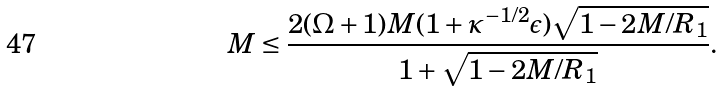Convert formula to latex. <formula><loc_0><loc_0><loc_500><loc_500>M \leq \frac { 2 ( \Omega + 1 ) M ( 1 + \kappa ^ { - 1 / 2 } \epsilon ) \sqrt { 1 - 2 M / R _ { 1 } } } { 1 + \sqrt { 1 - 2 M / R _ { 1 } } } .</formula> 